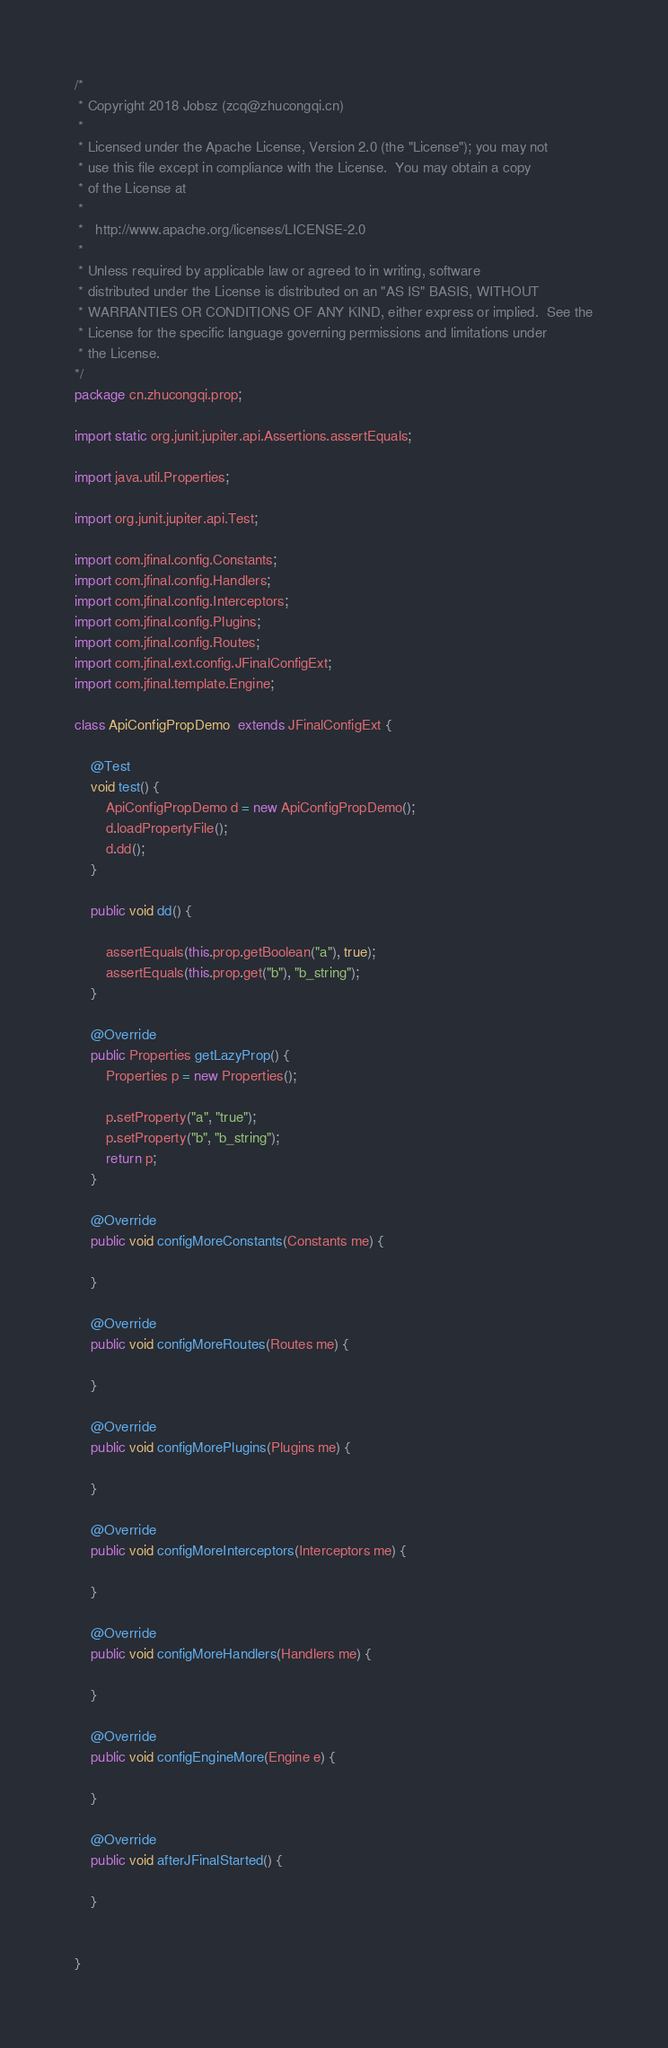<code> <loc_0><loc_0><loc_500><loc_500><_Java_>/*
 * Copyright 2018 Jobsz (zcq@zhucongqi.cn)
 * 
 * Licensed under the Apache License, Version 2.0 (the "License"); you may not
 * use this file except in compliance with the License.  You may obtain a copy
 * of the License at
 * 
 *   http://www.apache.org/licenses/LICENSE-2.0
 * 
 * Unless required by applicable law or agreed to in writing, software
 * distributed under the License is distributed on an "AS IS" BASIS, WITHOUT
 * WARRANTIES OR CONDITIONS OF ANY KIND, either express or implied.  See the
 * License for the specific language governing permissions and limitations under
 * the License.
*/
package cn.zhucongqi.prop;

import static org.junit.jupiter.api.Assertions.assertEquals;

import java.util.Properties;

import org.junit.jupiter.api.Test;

import com.jfinal.config.Constants;
import com.jfinal.config.Handlers;
import com.jfinal.config.Interceptors;
import com.jfinal.config.Plugins;
import com.jfinal.config.Routes;
import com.jfinal.ext.config.JFinalConfigExt;
import com.jfinal.template.Engine;

class ApiConfigPropDemo  extends JFinalConfigExt {

	@Test
	void test() {
		ApiConfigPropDemo d = new ApiConfigPropDemo();
		d.loadPropertyFile();
		d.dd();
	}
	
	public void dd() {
		
		assertEquals(this.prop.getBoolean("a"), true);
		assertEquals(this.prop.get("b"), "b_string");
	}

	@Override
	public Properties getLazyProp() {
		Properties p = new Properties();
		
		p.setProperty("a", "true");
		p.setProperty("b", "b_string");
		return p;
	}

	@Override
	public void configMoreConstants(Constants me) {
		
	}

	@Override
	public void configMoreRoutes(Routes me) {
		
	}

	@Override
	public void configMorePlugins(Plugins me) {
		
	}

	@Override
	public void configMoreInterceptors(Interceptors me) {
		
	}

	@Override
	public void configMoreHandlers(Handlers me) {
		
	}

	@Override
	public void configEngineMore(Engine e) {
		
	}

	@Override
	public void afterJFinalStarted() {
		
	}

	
}
</code> 